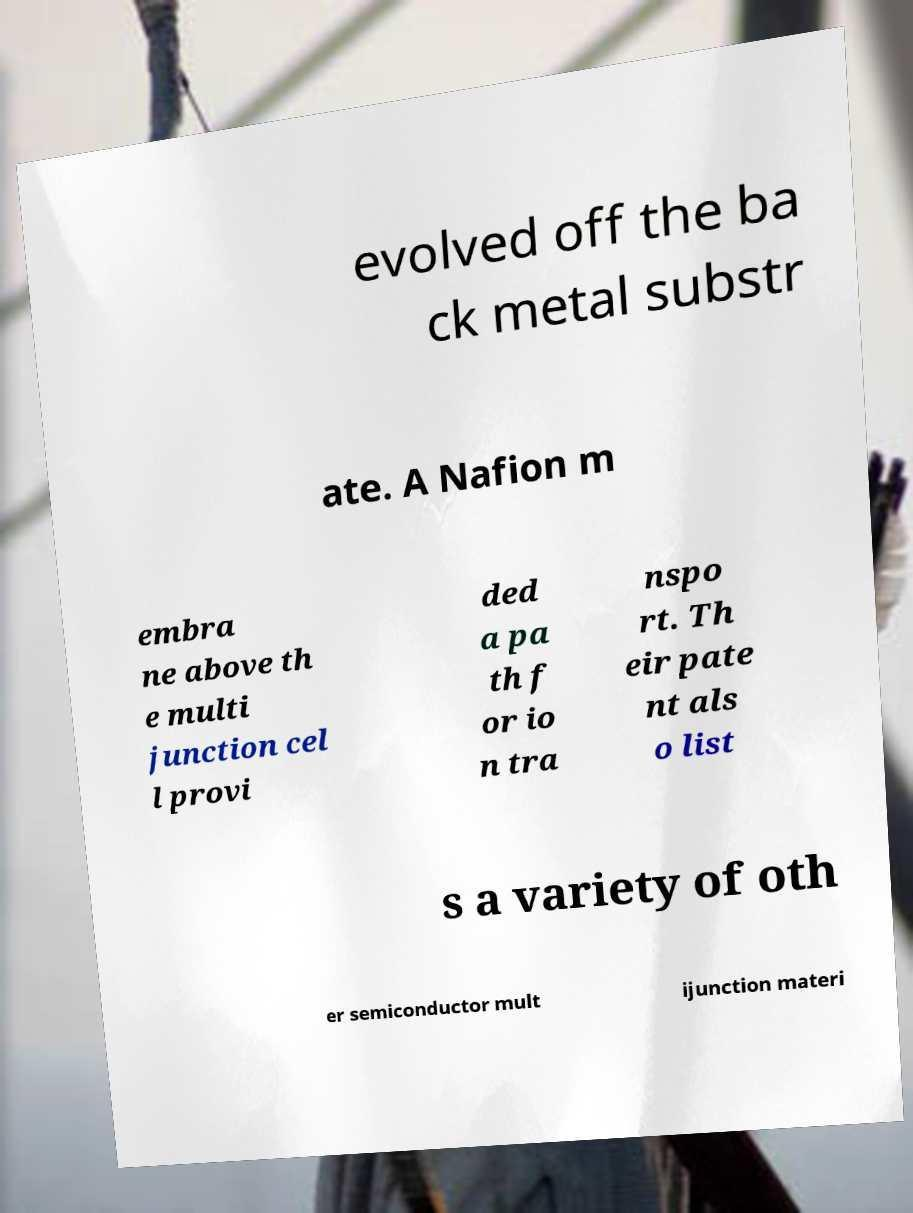There's text embedded in this image that I need extracted. Can you transcribe it verbatim? evolved off the ba ck metal substr ate. A Nafion m embra ne above th e multi junction cel l provi ded a pa th f or io n tra nspo rt. Th eir pate nt als o list s a variety of oth er semiconductor mult ijunction materi 